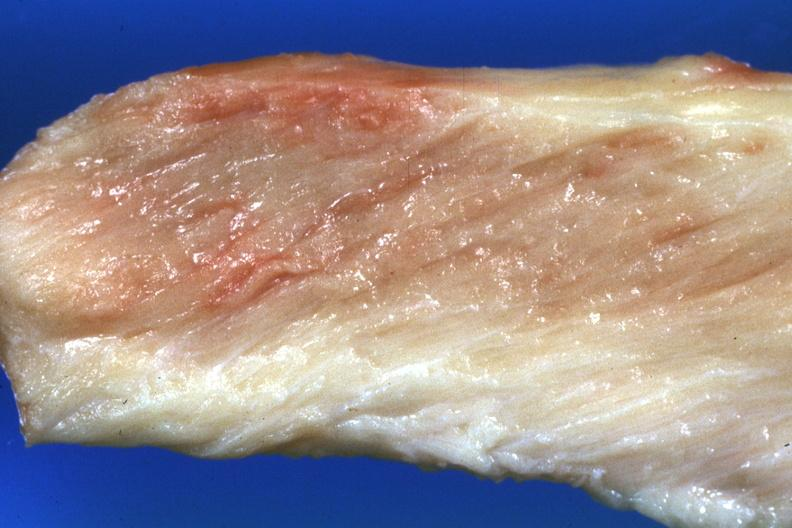s soft tissue present?
Answer the question using a single word or phrase. Yes 